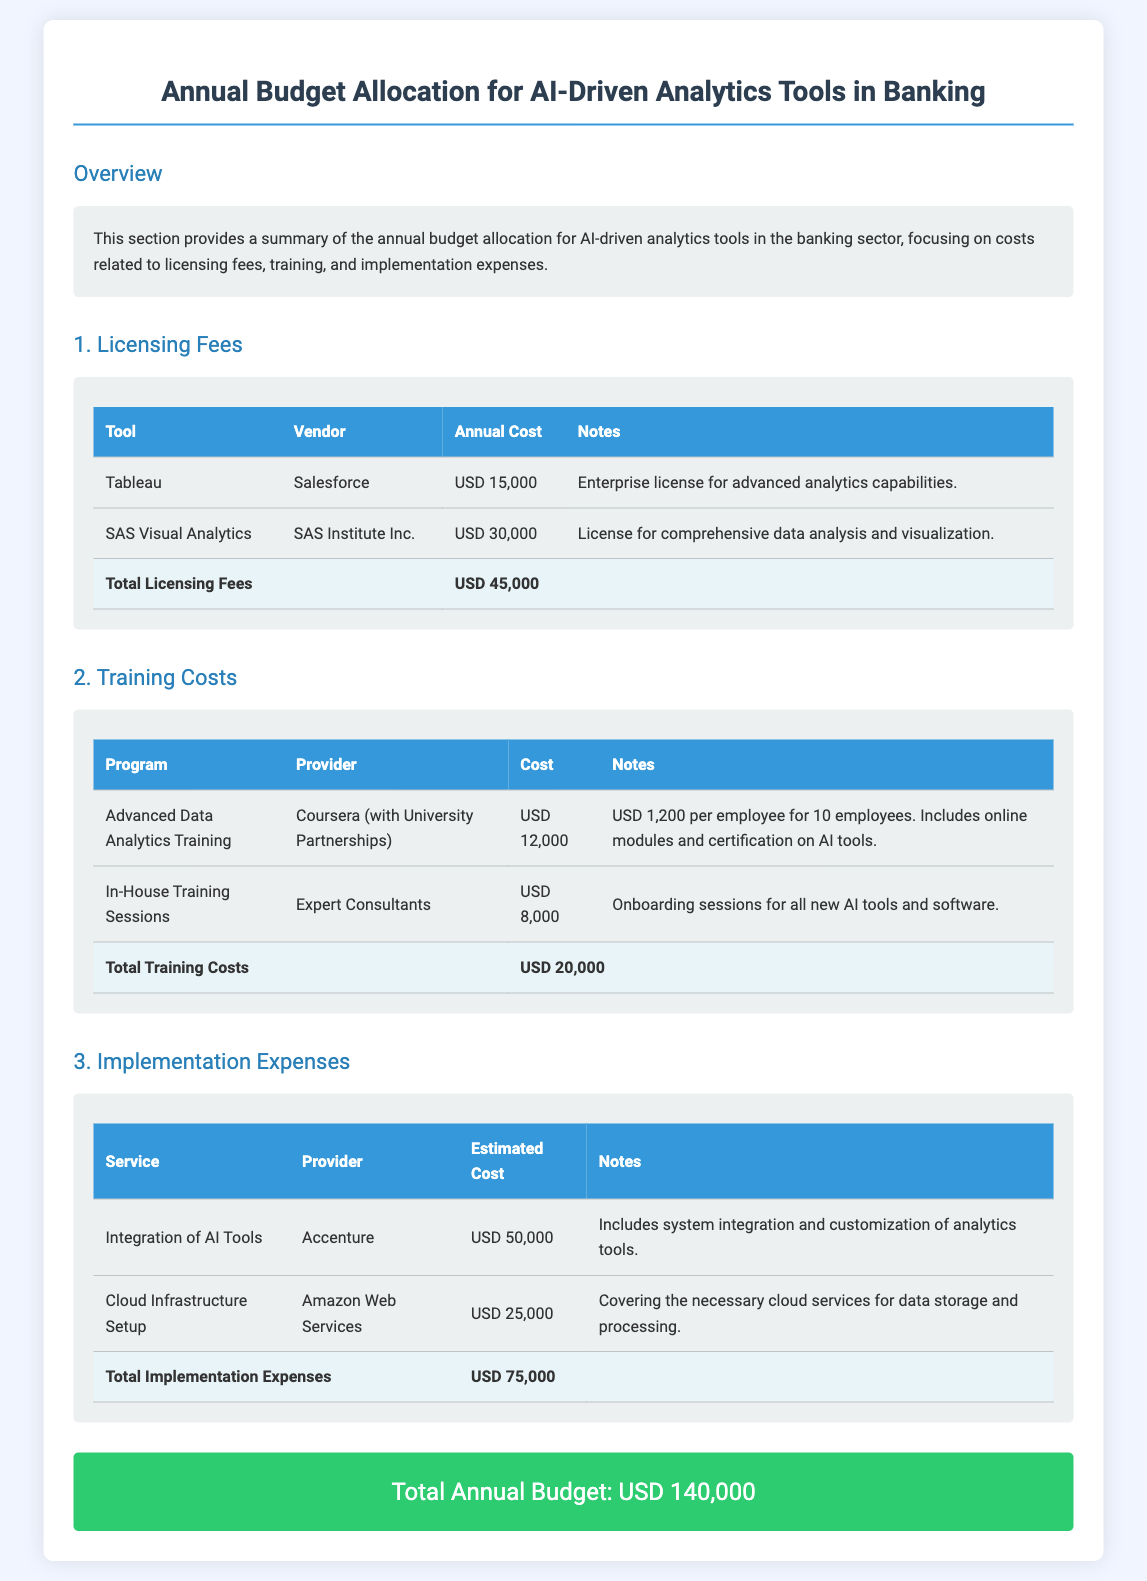What is the total licensing fees? The total licensing fees are the sum of the annual costs for all listed tools, which is USD 15,000 + USD 30,000.
Answer: USD 45,000 Who is the vendor for SAS Visual Analytics? The vendor for SAS Visual Analytics is specified in the document.
Answer: SAS Institute Inc How much is allocated for training costs? The total training costs represent the sum of the costs for the training programs listed, which is USD 12,000 + USD 8,000.
Answer: USD 20,000 What is the estimated cost for the integration of AI tools? The estimated cost for the integration of AI tools is provided in the implementation expenses section.
Answer: USD 50,000 What is the total annual budget? The total annual budget is the sum of all costs listed under licensing fees, training costs, and implementation expenses.
Answer: USD 140,000 Which program has a cost of USD 12,000? The program costing USD 12,000 is outlined in the training costs section of the document.
Answer: Advanced Data Analytics Training How many employees does the Advanced Data Analytics Training cover? The training sessions are noted to include a specific number of employees in the document.
Answer: 10 employees What provider is responsible for the cloud infrastructure setup? The provider for cloud infrastructure setup is mentioned in the implementation expenses section.
Answer: Amazon Web Services What is included in the license for Tableau? The notes under the licensing fees detail what the Tableau license includes.
Answer: Advanced analytics capabilities 